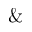<formula> <loc_0><loc_0><loc_500><loc_500>\&</formula> 